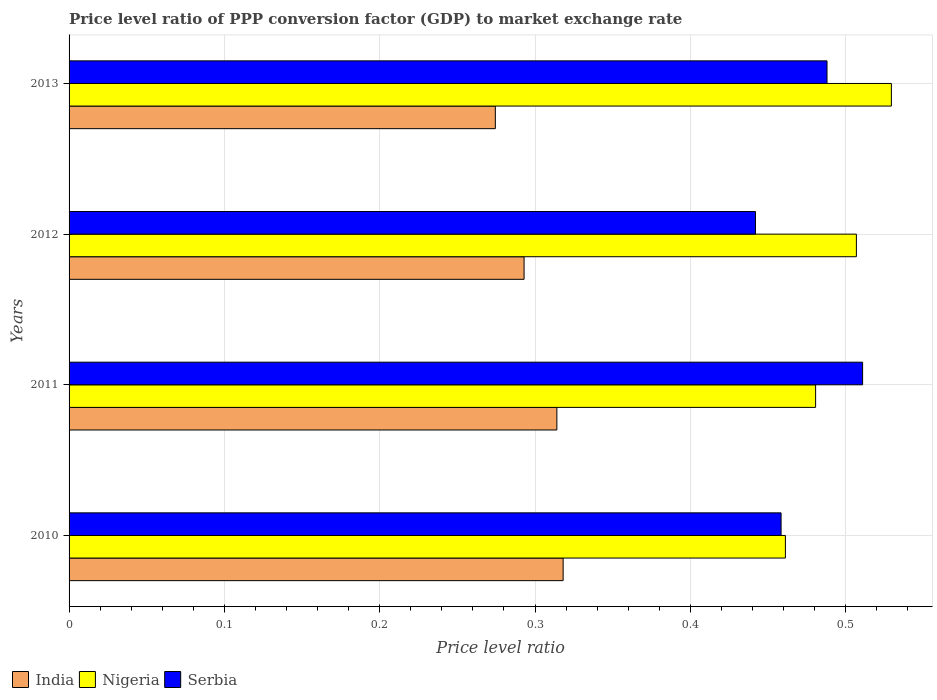Are the number of bars on each tick of the Y-axis equal?
Provide a succinct answer. Yes. How many bars are there on the 3rd tick from the top?
Your answer should be very brief. 3. In how many cases, is the number of bars for a given year not equal to the number of legend labels?
Offer a terse response. 0. What is the price level ratio in India in 2010?
Offer a very short reply. 0.32. Across all years, what is the maximum price level ratio in India?
Provide a short and direct response. 0.32. Across all years, what is the minimum price level ratio in Serbia?
Provide a succinct answer. 0.44. In which year was the price level ratio in Serbia maximum?
Provide a succinct answer. 2011. What is the total price level ratio in Nigeria in the graph?
Your answer should be very brief. 1.98. What is the difference between the price level ratio in Nigeria in 2010 and that in 2012?
Give a very brief answer. -0.05. What is the difference between the price level ratio in India in 2010 and the price level ratio in Nigeria in 2011?
Provide a succinct answer. -0.16. What is the average price level ratio in Nigeria per year?
Keep it short and to the point. 0.49. In the year 2011, what is the difference between the price level ratio in Serbia and price level ratio in India?
Keep it short and to the point. 0.2. What is the ratio of the price level ratio in India in 2010 to that in 2013?
Give a very brief answer. 1.16. What is the difference between the highest and the second highest price level ratio in Nigeria?
Your answer should be compact. 0.02. What is the difference between the highest and the lowest price level ratio in India?
Keep it short and to the point. 0.04. In how many years, is the price level ratio in Nigeria greater than the average price level ratio in Nigeria taken over all years?
Your answer should be very brief. 2. How many bars are there?
Keep it short and to the point. 12. What is the difference between two consecutive major ticks on the X-axis?
Your answer should be compact. 0.1. Are the values on the major ticks of X-axis written in scientific E-notation?
Keep it short and to the point. No. Does the graph contain any zero values?
Provide a short and direct response. No. How are the legend labels stacked?
Keep it short and to the point. Horizontal. What is the title of the graph?
Keep it short and to the point. Price level ratio of PPP conversion factor (GDP) to market exchange rate. Does "Iran" appear as one of the legend labels in the graph?
Keep it short and to the point. No. What is the label or title of the X-axis?
Provide a succinct answer. Price level ratio. What is the label or title of the Y-axis?
Provide a short and direct response. Years. What is the Price level ratio in India in 2010?
Make the answer very short. 0.32. What is the Price level ratio in Nigeria in 2010?
Offer a very short reply. 0.46. What is the Price level ratio of Serbia in 2010?
Keep it short and to the point. 0.46. What is the Price level ratio of India in 2011?
Your answer should be compact. 0.31. What is the Price level ratio in Nigeria in 2011?
Provide a short and direct response. 0.48. What is the Price level ratio in Serbia in 2011?
Give a very brief answer. 0.51. What is the Price level ratio of India in 2012?
Ensure brevity in your answer.  0.29. What is the Price level ratio in Nigeria in 2012?
Make the answer very short. 0.51. What is the Price level ratio in Serbia in 2012?
Give a very brief answer. 0.44. What is the Price level ratio of India in 2013?
Offer a very short reply. 0.27. What is the Price level ratio of Nigeria in 2013?
Provide a short and direct response. 0.53. What is the Price level ratio of Serbia in 2013?
Provide a short and direct response. 0.49. Across all years, what is the maximum Price level ratio in India?
Offer a terse response. 0.32. Across all years, what is the maximum Price level ratio of Nigeria?
Keep it short and to the point. 0.53. Across all years, what is the maximum Price level ratio of Serbia?
Provide a succinct answer. 0.51. Across all years, what is the minimum Price level ratio in India?
Make the answer very short. 0.27. Across all years, what is the minimum Price level ratio of Nigeria?
Give a very brief answer. 0.46. Across all years, what is the minimum Price level ratio in Serbia?
Your answer should be very brief. 0.44. What is the total Price level ratio of India in the graph?
Your answer should be compact. 1.2. What is the total Price level ratio of Nigeria in the graph?
Your answer should be compact. 1.98. What is the total Price level ratio in Serbia in the graph?
Your answer should be compact. 1.9. What is the difference between the Price level ratio of India in 2010 and that in 2011?
Offer a terse response. 0. What is the difference between the Price level ratio in Nigeria in 2010 and that in 2011?
Make the answer very short. -0.02. What is the difference between the Price level ratio in Serbia in 2010 and that in 2011?
Offer a very short reply. -0.05. What is the difference between the Price level ratio of India in 2010 and that in 2012?
Offer a terse response. 0.03. What is the difference between the Price level ratio of Nigeria in 2010 and that in 2012?
Your answer should be very brief. -0.05. What is the difference between the Price level ratio in Serbia in 2010 and that in 2012?
Offer a terse response. 0.02. What is the difference between the Price level ratio in India in 2010 and that in 2013?
Your response must be concise. 0.04. What is the difference between the Price level ratio of Nigeria in 2010 and that in 2013?
Your answer should be very brief. -0.07. What is the difference between the Price level ratio of Serbia in 2010 and that in 2013?
Offer a very short reply. -0.03. What is the difference between the Price level ratio in India in 2011 and that in 2012?
Give a very brief answer. 0.02. What is the difference between the Price level ratio in Nigeria in 2011 and that in 2012?
Provide a succinct answer. -0.03. What is the difference between the Price level ratio in Serbia in 2011 and that in 2012?
Offer a terse response. 0.07. What is the difference between the Price level ratio of India in 2011 and that in 2013?
Your answer should be compact. 0.04. What is the difference between the Price level ratio in Nigeria in 2011 and that in 2013?
Your response must be concise. -0.05. What is the difference between the Price level ratio of Serbia in 2011 and that in 2013?
Offer a very short reply. 0.02. What is the difference between the Price level ratio in India in 2012 and that in 2013?
Ensure brevity in your answer.  0.02. What is the difference between the Price level ratio in Nigeria in 2012 and that in 2013?
Offer a terse response. -0.02. What is the difference between the Price level ratio of Serbia in 2012 and that in 2013?
Your response must be concise. -0.05. What is the difference between the Price level ratio in India in 2010 and the Price level ratio in Nigeria in 2011?
Ensure brevity in your answer.  -0.16. What is the difference between the Price level ratio of India in 2010 and the Price level ratio of Serbia in 2011?
Your response must be concise. -0.19. What is the difference between the Price level ratio of Nigeria in 2010 and the Price level ratio of Serbia in 2011?
Ensure brevity in your answer.  -0.05. What is the difference between the Price level ratio of India in 2010 and the Price level ratio of Nigeria in 2012?
Keep it short and to the point. -0.19. What is the difference between the Price level ratio of India in 2010 and the Price level ratio of Serbia in 2012?
Your answer should be compact. -0.12. What is the difference between the Price level ratio in Nigeria in 2010 and the Price level ratio in Serbia in 2012?
Provide a short and direct response. 0.02. What is the difference between the Price level ratio of India in 2010 and the Price level ratio of Nigeria in 2013?
Provide a short and direct response. -0.21. What is the difference between the Price level ratio in India in 2010 and the Price level ratio in Serbia in 2013?
Keep it short and to the point. -0.17. What is the difference between the Price level ratio in Nigeria in 2010 and the Price level ratio in Serbia in 2013?
Your answer should be compact. -0.03. What is the difference between the Price level ratio of India in 2011 and the Price level ratio of Nigeria in 2012?
Your response must be concise. -0.19. What is the difference between the Price level ratio of India in 2011 and the Price level ratio of Serbia in 2012?
Offer a terse response. -0.13. What is the difference between the Price level ratio of Nigeria in 2011 and the Price level ratio of Serbia in 2012?
Give a very brief answer. 0.04. What is the difference between the Price level ratio of India in 2011 and the Price level ratio of Nigeria in 2013?
Your answer should be very brief. -0.22. What is the difference between the Price level ratio of India in 2011 and the Price level ratio of Serbia in 2013?
Your answer should be compact. -0.17. What is the difference between the Price level ratio in Nigeria in 2011 and the Price level ratio in Serbia in 2013?
Provide a short and direct response. -0.01. What is the difference between the Price level ratio of India in 2012 and the Price level ratio of Nigeria in 2013?
Make the answer very short. -0.24. What is the difference between the Price level ratio of India in 2012 and the Price level ratio of Serbia in 2013?
Make the answer very short. -0.2. What is the difference between the Price level ratio of Nigeria in 2012 and the Price level ratio of Serbia in 2013?
Make the answer very short. 0.02. What is the average Price level ratio of India per year?
Provide a short and direct response. 0.3. What is the average Price level ratio in Nigeria per year?
Provide a succinct answer. 0.49. What is the average Price level ratio in Serbia per year?
Your response must be concise. 0.47. In the year 2010, what is the difference between the Price level ratio in India and Price level ratio in Nigeria?
Provide a short and direct response. -0.14. In the year 2010, what is the difference between the Price level ratio in India and Price level ratio in Serbia?
Make the answer very short. -0.14. In the year 2010, what is the difference between the Price level ratio of Nigeria and Price level ratio of Serbia?
Your answer should be compact. 0. In the year 2011, what is the difference between the Price level ratio in India and Price level ratio in Nigeria?
Ensure brevity in your answer.  -0.17. In the year 2011, what is the difference between the Price level ratio of India and Price level ratio of Serbia?
Give a very brief answer. -0.2. In the year 2011, what is the difference between the Price level ratio in Nigeria and Price level ratio in Serbia?
Your answer should be very brief. -0.03. In the year 2012, what is the difference between the Price level ratio of India and Price level ratio of Nigeria?
Make the answer very short. -0.21. In the year 2012, what is the difference between the Price level ratio of India and Price level ratio of Serbia?
Your response must be concise. -0.15. In the year 2012, what is the difference between the Price level ratio of Nigeria and Price level ratio of Serbia?
Offer a terse response. 0.07. In the year 2013, what is the difference between the Price level ratio of India and Price level ratio of Nigeria?
Offer a very short reply. -0.26. In the year 2013, what is the difference between the Price level ratio in India and Price level ratio in Serbia?
Your response must be concise. -0.21. In the year 2013, what is the difference between the Price level ratio of Nigeria and Price level ratio of Serbia?
Provide a short and direct response. 0.04. What is the ratio of the Price level ratio of India in 2010 to that in 2011?
Ensure brevity in your answer.  1.01. What is the ratio of the Price level ratio of Nigeria in 2010 to that in 2011?
Your response must be concise. 0.96. What is the ratio of the Price level ratio in Serbia in 2010 to that in 2011?
Make the answer very short. 0.9. What is the ratio of the Price level ratio in India in 2010 to that in 2012?
Provide a succinct answer. 1.09. What is the ratio of the Price level ratio in Nigeria in 2010 to that in 2012?
Provide a short and direct response. 0.91. What is the ratio of the Price level ratio in Serbia in 2010 to that in 2012?
Offer a terse response. 1.04. What is the ratio of the Price level ratio in India in 2010 to that in 2013?
Provide a short and direct response. 1.16. What is the ratio of the Price level ratio of Nigeria in 2010 to that in 2013?
Make the answer very short. 0.87. What is the ratio of the Price level ratio in Serbia in 2010 to that in 2013?
Offer a very short reply. 0.94. What is the ratio of the Price level ratio of India in 2011 to that in 2012?
Your answer should be very brief. 1.07. What is the ratio of the Price level ratio in Nigeria in 2011 to that in 2012?
Offer a terse response. 0.95. What is the ratio of the Price level ratio of Serbia in 2011 to that in 2012?
Keep it short and to the point. 1.16. What is the ratio of the Price level ratio of India in 2011 to that in 2013?
Offer a very short reply. 1.14. What is the ratio of the Price level ratio of Nigeria in 2011 to that in 2013?
Your response must be concise. 0.91. What is the ratio of the Price level ratio of Serbia in 2011 to that in 2013?
Offer a very short reply. 1.05. What is the ratio of the Price level ratio in India in 2012 to that in 2013?
Keep it short and to the point. 1.07. What is the ratio of the Price level ratio of Nigeria in 2012 to that in 2013?
Provide a short and direct response. 0.96. What is the ratio of the Price level ratio of Serbia in 2012 to that in 2013?
Your answer should be very brief. 0.91. What is the difference between the highest and the second highest Price level ratio in India?
Offer a very short reply. 0. What is the difference between the highest and the second highest Price level ratio in Nigeria?
Offer a very short reply. 0.02. What is the difference between the highest and the second highest Price level ratio of Serbia?
Offer a terse response. 0.02. What is the difference between the highest and the lowest Price level ratio of India?
Offer a very short reply. 0.04. What is the difference between the highest and the lowest Price level ratio in Nigeria?
Offer a very short reply. 0.07. What is the difference between the highest and the lowest Price level ratio in Serbia?
Keep it short and to the point. 0.07. 